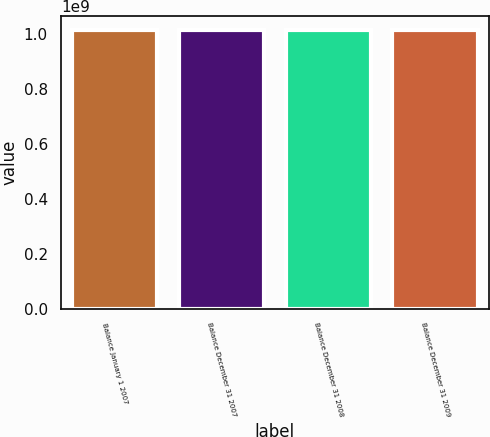Convert chart. <chart><loc_0><loc_0><loc_500><loc_500><bar_chart><fcel>Balance January 1 2007<fcel>Balance December 31 2007<fcel>Balance December 31 2008<fcel>Balance December 31 2009<nl><fcel>1.01226e+09<fcel>1.01226e+09<fcel>1.01226e+09<fcel>1.01226e+09<nl></chart> 